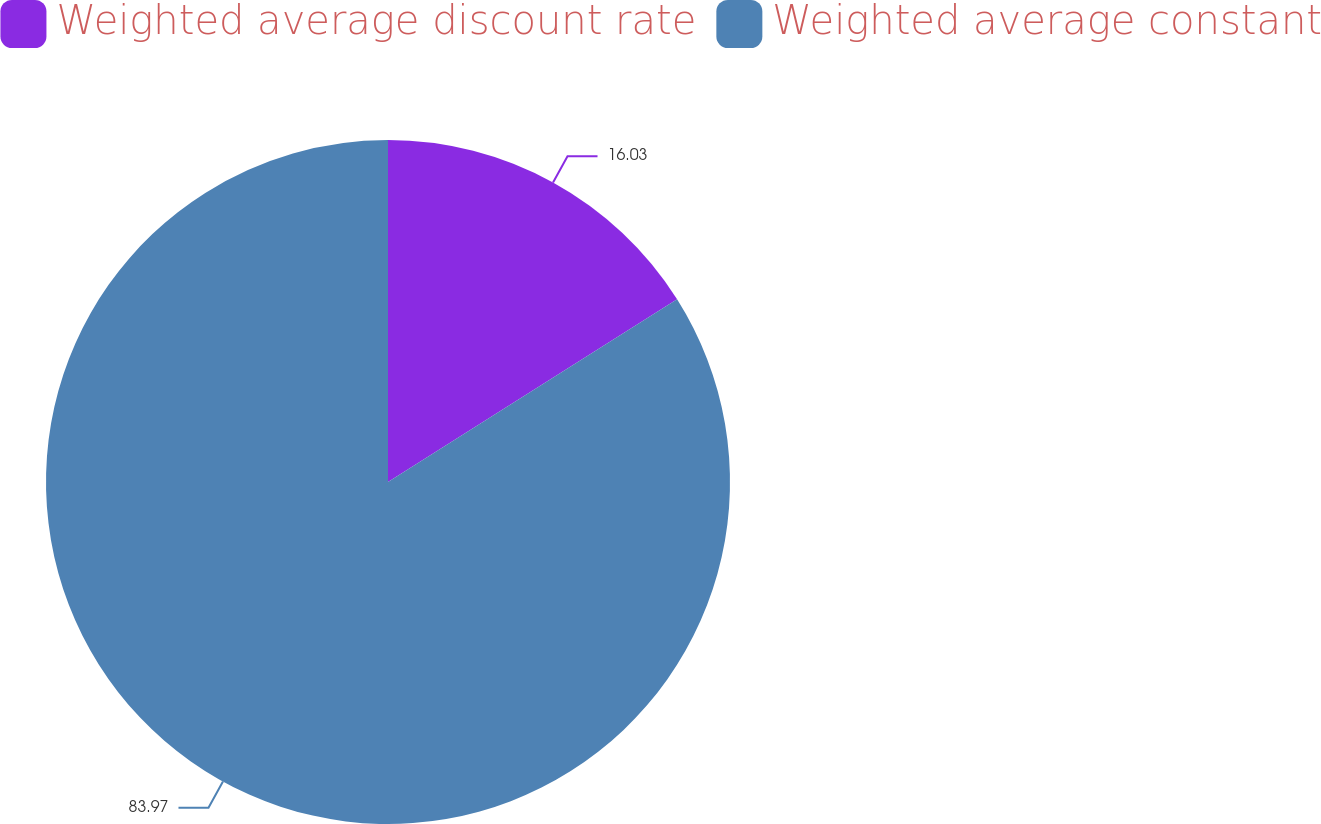Convert chart. <chart><loc_0><loc_0><loc_500><loc_500><pie_chart><fcel>Weighted average discount rate<fcel>Weighted average constant<nl><fcel>16.03%<fcel>83.97%<nl></chart> 